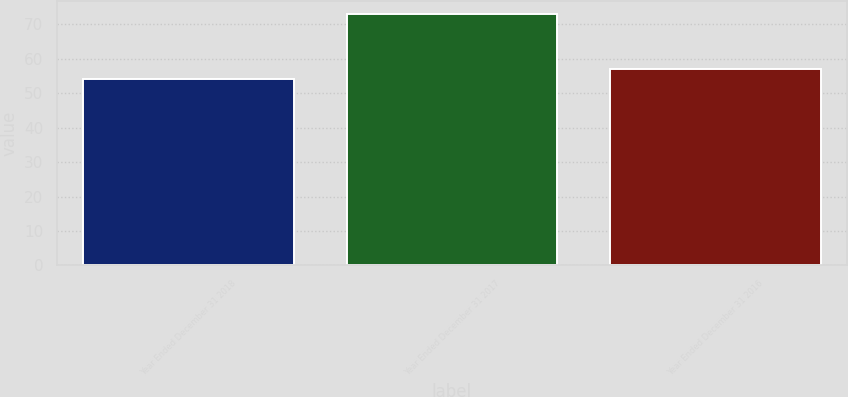Convert chart. <chart><loc_0><loc_0><loc_500><loc_500><bar_chart><fcel>Year Ended December 31 2018<fcel>Year Ended December 31 2017<fcel>Year Ended December 31 2016<nl><fcel>54<fcel>73<fcel>57<nl></chart> 